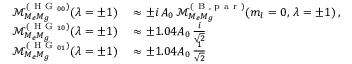<formula> <loc_0><loc_0><loc_500><loc_500>\begin{array} { r l } { \mathcal { M } _ { M _ { e } M _ { g } } ^ { ( H G _ { 0 0 } ) } ( \lambda = \pm 1 ) } & \approx \pm i \, A _ { 0 } \, \mathcal { M } _ { M _ { e } M _ { g } } ^ { ( B , p a r ) } ( m _ { l } = 0 , \, \lambda = \pm 1 ) \, , } \\ { \mathcal { M } _ { M _ { e } M _ { g } } ^ { ( H G _ { 1 0 } ) } ( \lambda = \pm 1 ) } & \approx \pm 1 . 0 4 A _ { 0 } \, \frac { i } { \sqrt { 2 } } } \\ { \mathcal { M } _ { M _ { e } M _ { g } } ^ { ( H G _ { 0 1 } ) } ( \lambda = \pm 1 ) } & \approx \pm 1 . 0 4 A _ { 0 } \, \frac { 1 } { \sqrt { 2 } } } \end{array}</formula> 